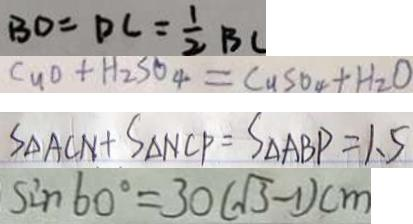<formula> <loc_0><loc_0><loc_500><loc_500>B D = D C = \frac { 1 } { 2 } B C 
 C u + H _ { 2 } S O _ { 4 } = C u S O _ { 4 } + H _ { 2 } O 
 S _ { \Delta A C N } + S _ { \Delta N C P } = S _ { \Delta } A B P = 1 . 5 
 \sin 6 0 ^ { \circ } = 3 0 ( \sqrt { 3 } - 1 ) c m</formula> 